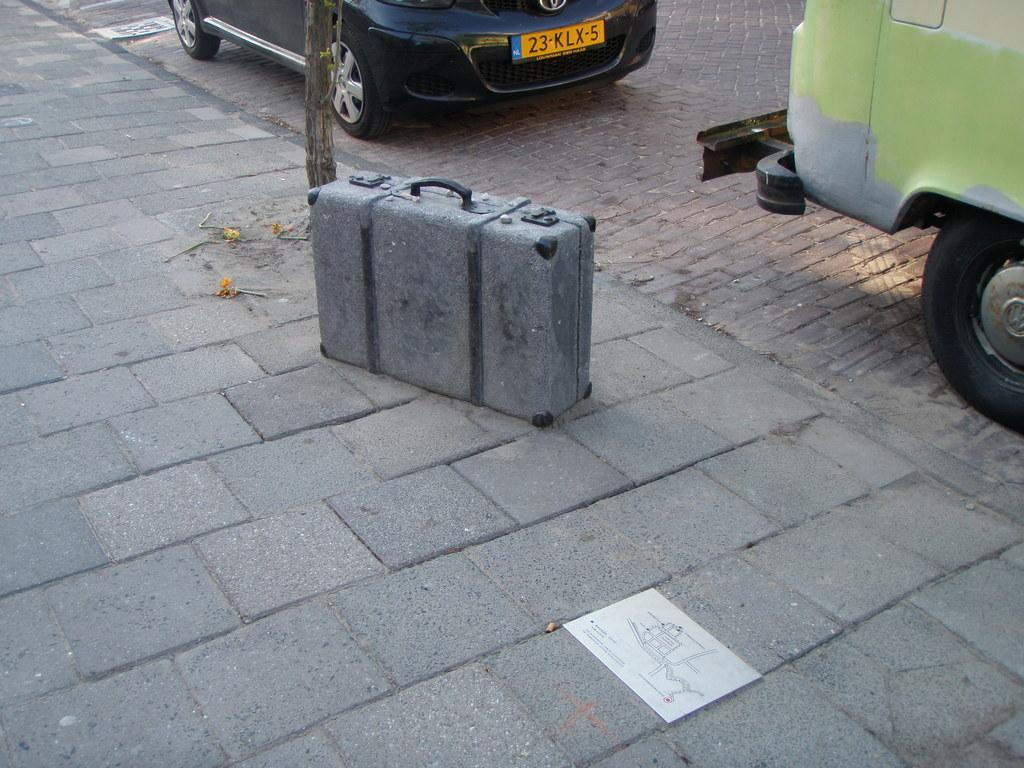What object can be seen on the side of the road in the image? There is a suitcase on the side of a road in the image. What can be observed about the vehicles in the image? There are two vehicles parked in a parking space in the image. What type of farm animals can be seen grazing near the parked vehicles in the image? There are no farm animals present in the image; it only features a suitcase on the side of the road and two parked vehicles. 